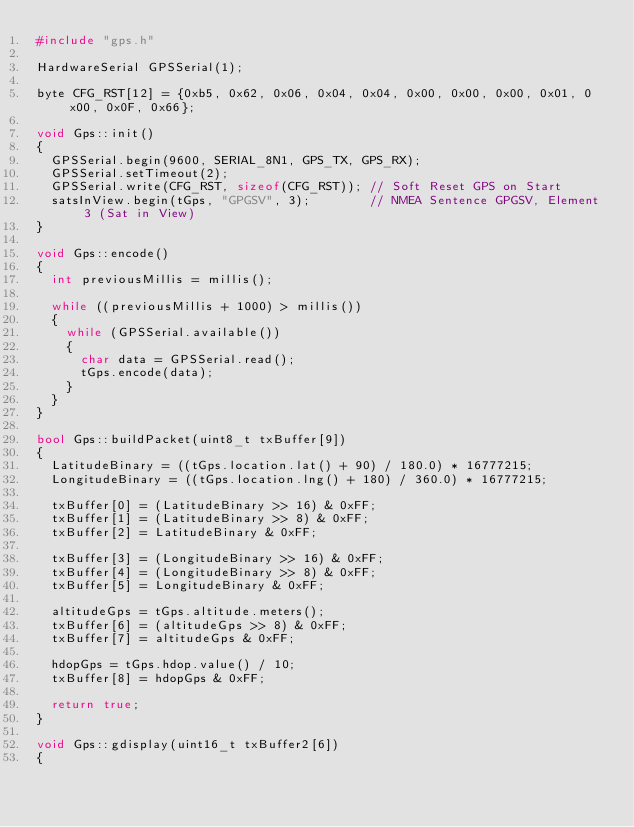Convert code to text. <code><loc_0><loc_0><loc_500><loc_500><_C++_>#include "gps.h"

HardwareSerial GPSSerial(1);

byte CFG_RST[12] = {0xb5, 0x62, 0x06, 0x04, 0x04, 0x00, 0x00, 0x00, 0x01, 0x00, 0x0F, 0x66};

void Gps::init()
{
  GPSSerial.begin(9600, SERIAL_8N1, GPS_TX, GPS_RX);
  GPSSerial.setTimeout(2);
  GPSSerial.write(CFG_RST, sizeof(CFG_RST)); // Soft Reset GPS on Start
  satsInView.begin(tGps, "GPGSV", 3);        // NMEA Sentence GPGSV, Element 3 (Sat in View)
}

void Gps::encode()
{
  int previousMillis = millis();

  while ((previousMillis + 1000) > millis())
  {
    while (GPSSerial.available())
    {
      char data = GPSSerial.read();
      tGps.encode(data);
    }
  }
}

bool Gps::buildPacket(uint8_t txBuffer[9])
{
  LatitudeBinary = ((tGps.location.lat() + 90) / 180.0) * 16777215;
  LongitudeBinary = ((tGps.location.lng() + 180) / 360.0) * 16777215;

  txBuffer[0] = (LatitudeBinary >> 16) & 0xFF;
  txBuffer[1] = (LatitudeBinary >> 8) & 0xFF;
  txBuffer[2] = LatitudeBinary & 0xFF;

  txBuffer[3] = (LongitudeBinary >> 16) & 0xFF;
  txBuffer[4] = (LongitudeBinary >> 8) & 0xFF;
  txBuffer[5] = LongitudeBinary & 0xFF;

  altitudeGps = tGps.altitude.meters();
  txBuffer[6] = (altitudeGps >> 8) & 0xFF;
  txBuffer[7] = altitudeGps & 0xFF;

  hdopGps = tGps.hdop.value() / 10;
  txBuffer[8] = hdopGps & 0xFF;

  return true;
}

void Gps::gdisplay(uint16_t txBuffer2[6])
{</code> 